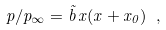Convert formula to latex. <formula><loc_0><loc_0><loc_500><loc_500>p / p _ { \infty } = \tilde { b } \, x ( x + x _ { 0 } ) \ ,</formula> 